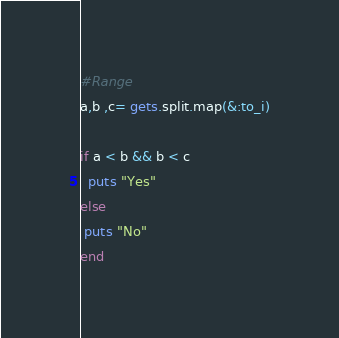Convert code to text. <code><loc_0><loc_0><loc_500><loc_500><_Ruby_>#Range
a,b ,c= gets.split.map(&:to_i)

if a < b && b < c
  puts "Yes"
else
 puts "No"
end</code> 